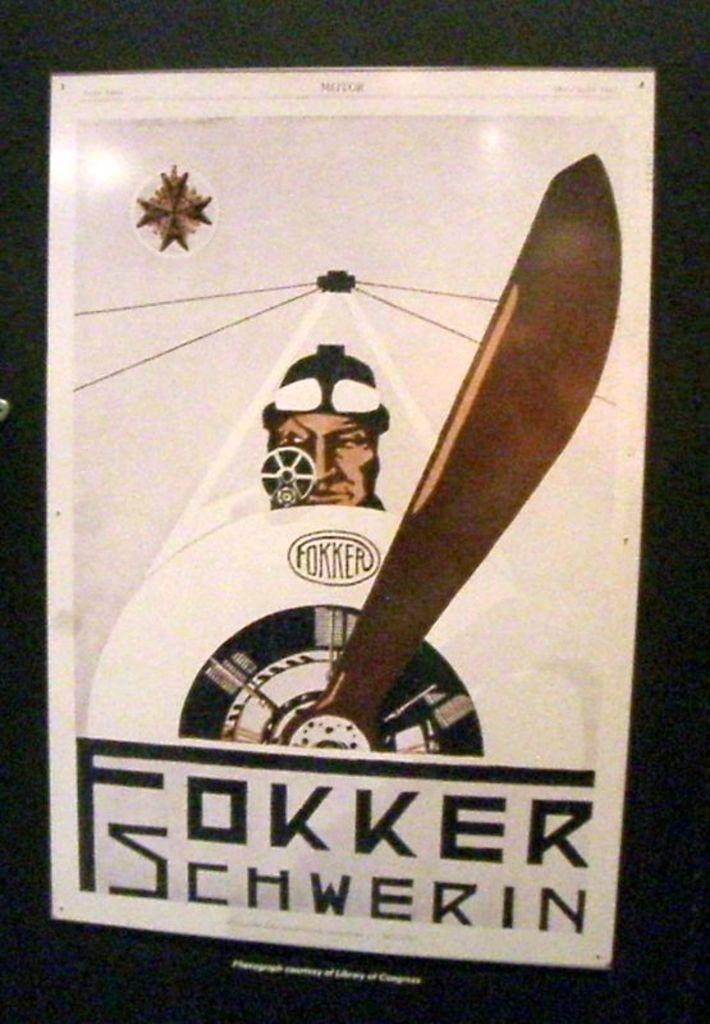Describe this image in one or two sentences. This is a poster and in this poster we can see a person, wheel and a hand on a clock. 